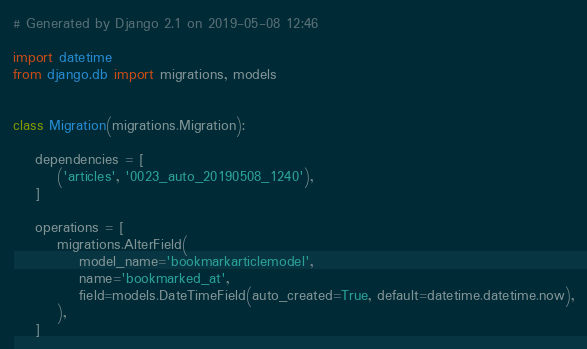Convert code to text. <code><loc_0><loc_0><loc_500><loc_500><_Python_># Generated by Django 2.1 on 2019-05-08 12:46

import datetime
from django.db import migrations, models


class Migration(migrations.Migration):

    dependencies = [
        ('articles', '0023_auto_20190508_1240'),
    ]

    operations = [
        migrations.AlterField(
            model_name='bookmarkarticlemodel',
            name='bookmarked_at',
            field=models.DateTimeField(auto_created=True, default=datetime.datetime.now),
        ),
    ]
</code> 